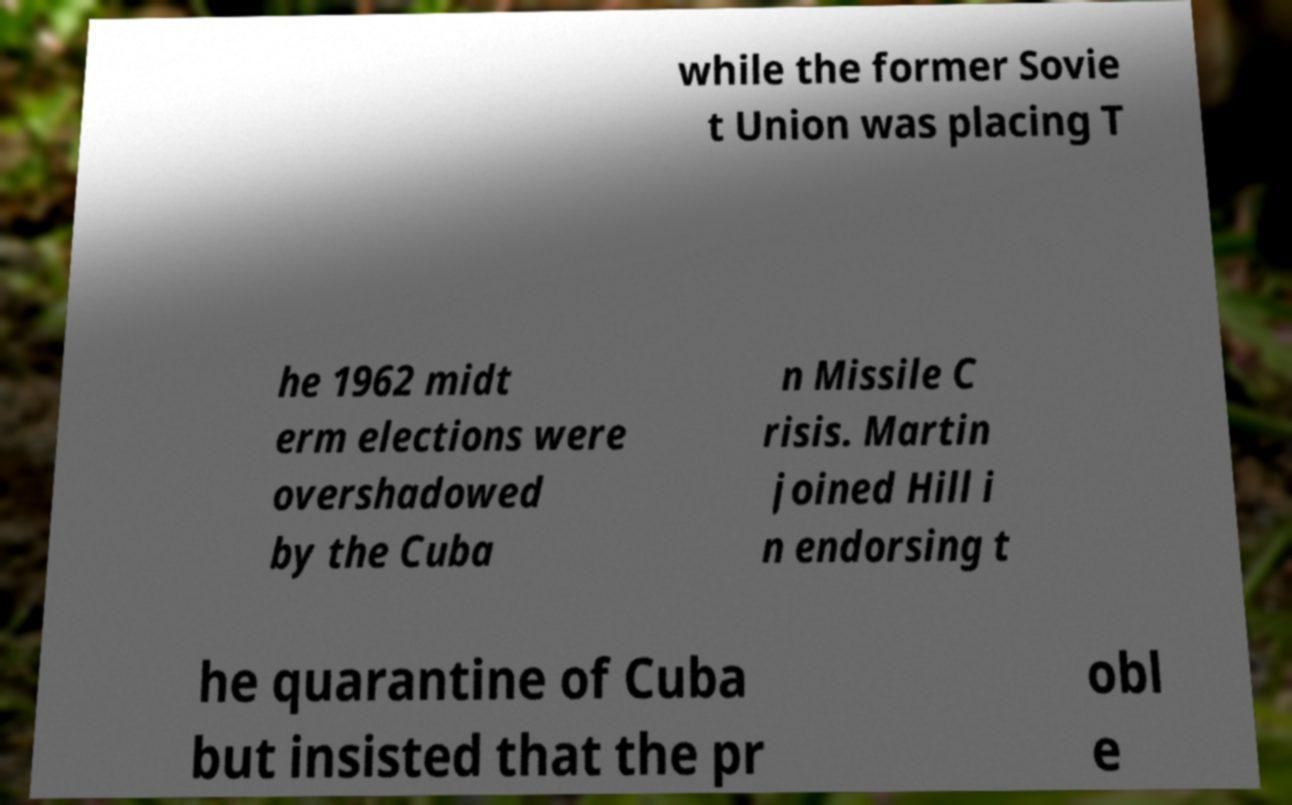Can you read and provide the text displayed in the image?This photo seems to have some interesting text. Can you extract and type it out for me? while the former Sovie t Union was placing T he 1962 midt erm elections were overshadowed by the Cuba n Missile C risis. Martin joined Hill i n endorsing t he quarantine of Cuba but insisted that the pr obl e 